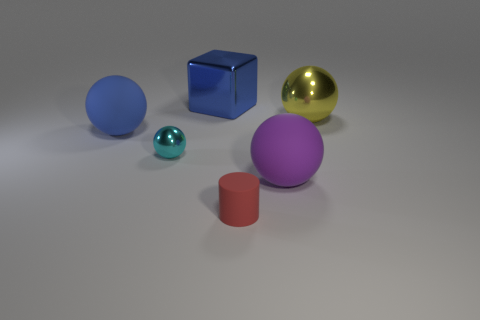Add 2 green rubber balls. How many objects exist? 8 Subtract all large blue balls. How many balls are left? 3 Subtract all cyan balls. How many balls are left? 3 Subtract all cylinders. How many objects are left? 5 Subtract all red balls. Subtract all big yellow shiny balls. How many objects are left? 5 Add 3 large yellow balls. How many large yellow balls are left? 4 Add 2 large red metallic objects. How many large red metallic objects exist? 2 Subtract 0 green blocks. How many objects are left? 6 Subtract all gray cubes. Subtract all brown cylinders. How many cubes are left? 1 